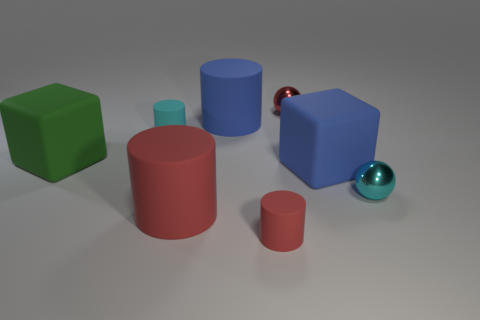Are there fewer blue metal cubes than big green cubes?
Provide a short and direct response. Yes. The object that is to the left of the tiny thing to the left of the small cylinder in front of the blue matte cube is what shape?
Make the answer very short. Cube. Are there any big red cylinders made of the same material as the red sphere?
Provide a short and direct response. No. There is a tiny matte object that is in front of the small cyan ball; is it the same color as the big rubber object that is in front of the cyan metallic object?
Keep it short and to the point. Yes. Are there fewer rubber cubes that are on the left side of the tiny red ball than big blue cylinders?
Keep it short and to the point. No. What number of objects are tiny red matte cylinders or large matte objects behind the tiny cyan metallic object?
Keep it short and to the point. 4. There is a small object that is made of the same material as the red sphere; what color is it?
Keep it short and to the point. Cyan. How many things are either small cyan balls or large cylinders?
Keep it short and to the point. 3. What color is the sphere that is the same size as the cyan shiny thing?
Give a very brief answer. Red. What number of objects are either blue matte blocks that are right of the red metal object or small blue rubber cylinders?
Give a very brief answer. 1. 